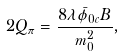<formula> <loc_0><loc_0><loc_500><loc_500>2 Q _ { \pi } = \frac { 8 \lambda \bar { \phi } _ { 0 c } B } { m _ { 0 } ^ { 2 } } ,</formula> 